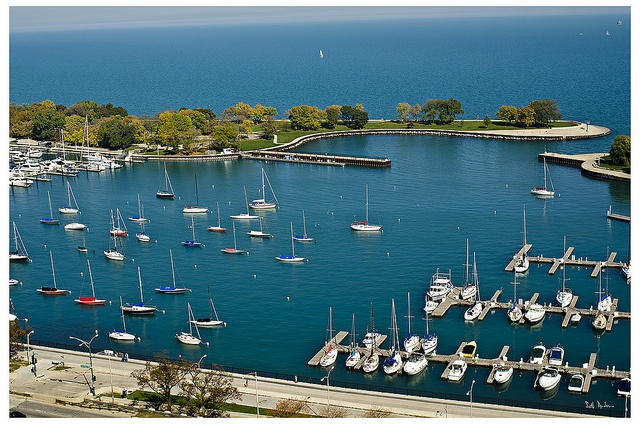Describe the objects in this image and their specific colors. I can see boat in white, ivory, darkgray, gray, and black tones, boat in white, darkgray, black, and gray tones, boat in white, blue, gray, and darkgray tones, boat in white, darkgray, blue, and black tones, and boat in white, darkgray, teal, and blue tones in this image. 